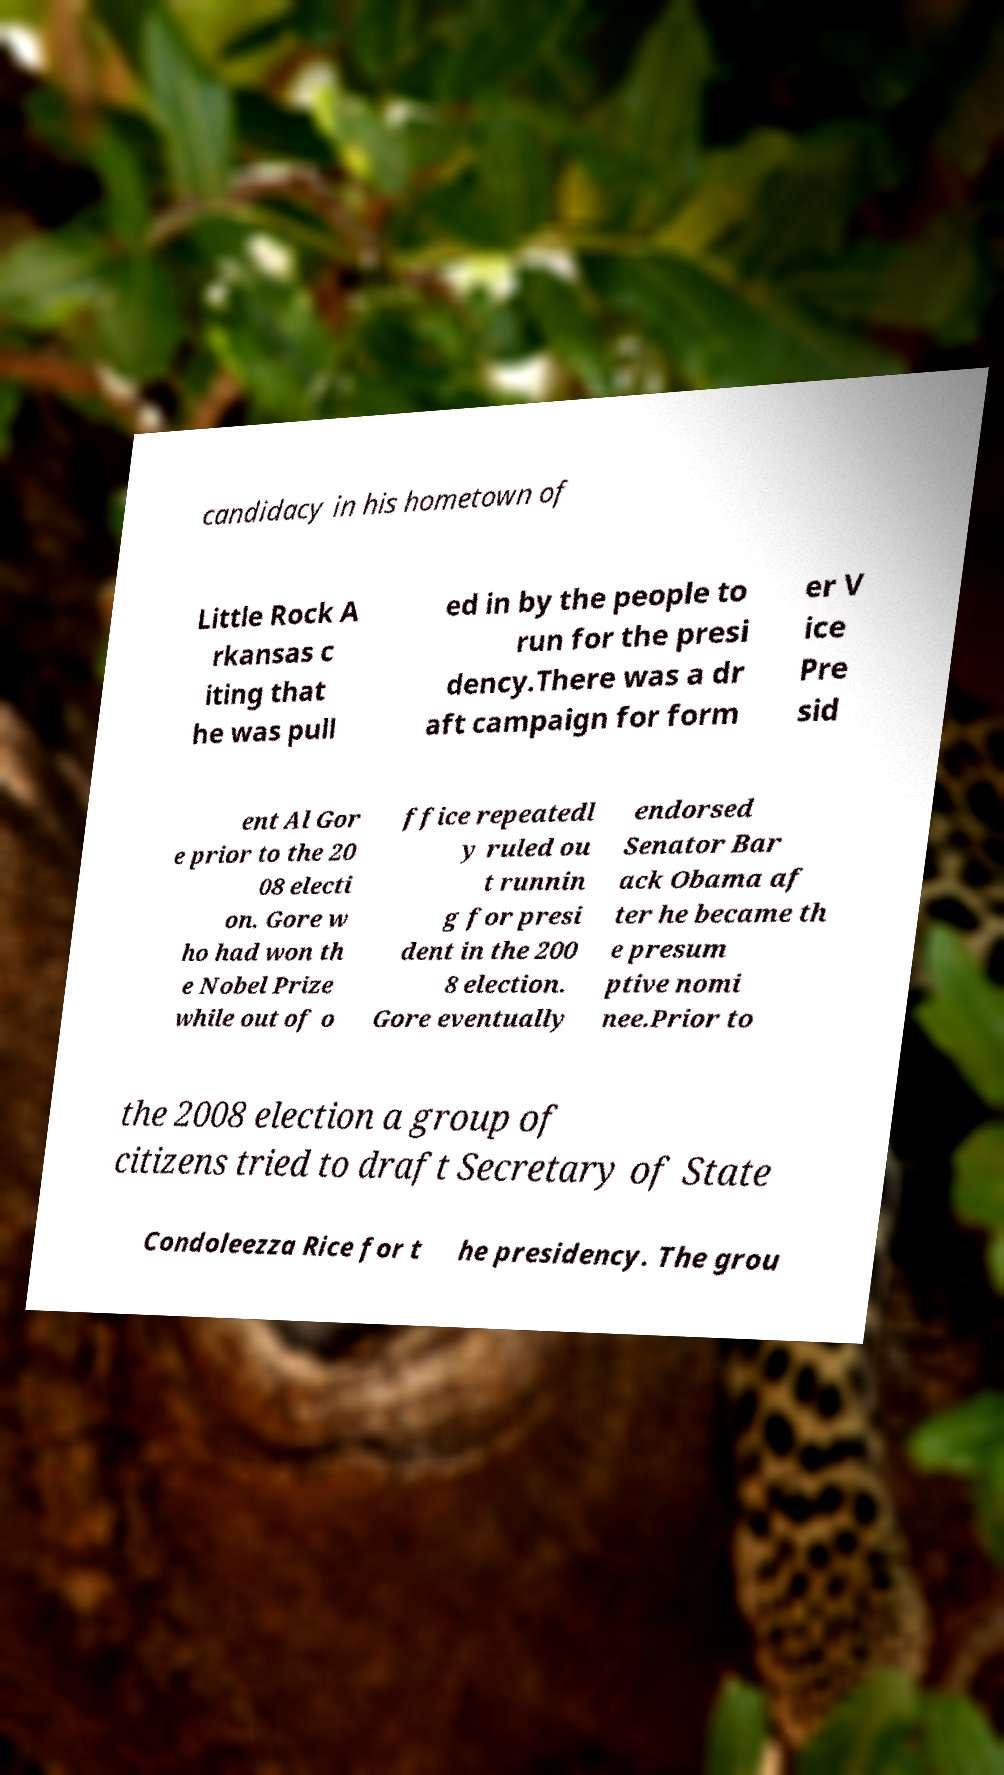I need the written content from this picture converted into text. Can you do that? candidacy in his hometown of Little Rock A rkansas c iting that he was pull ed in by the people to run for the presi dency.There was a dr aft campaign for form er V ice Pre sid ent Al Gor e prior to the 20 08 electi on. Gore w ho had won th e Nobel Prize while out of o ffice repeatedl y ruled ou t runnin g for presi dent in the 200 8 election. Gore eventually endorsed Senator Bar ack Obama af ter he became th e presum ptive nomi nee.Prior to the 2008 election a group of citizens tried to draft Secretary of State Condoleezza Rice for t he presidency. The grou 